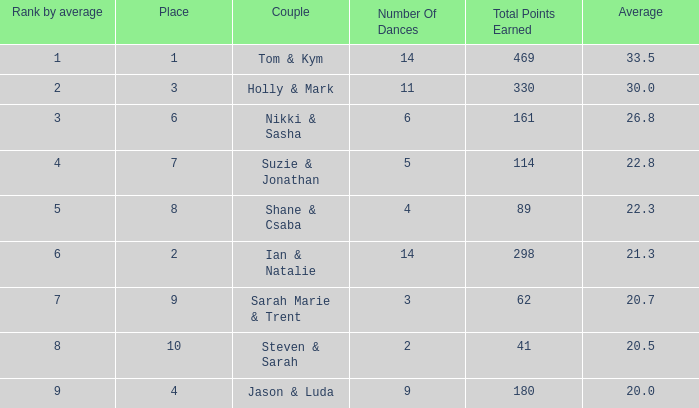3? 1.0. 